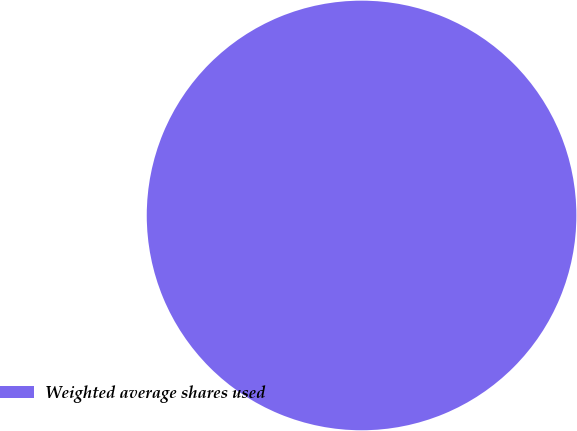Convert chart. <chart><loc_0><loc_0><loc_500><loc_500><pie_chart><fcel>Weighted average shares used<nl><fcel>100.0%<nl></chart> 